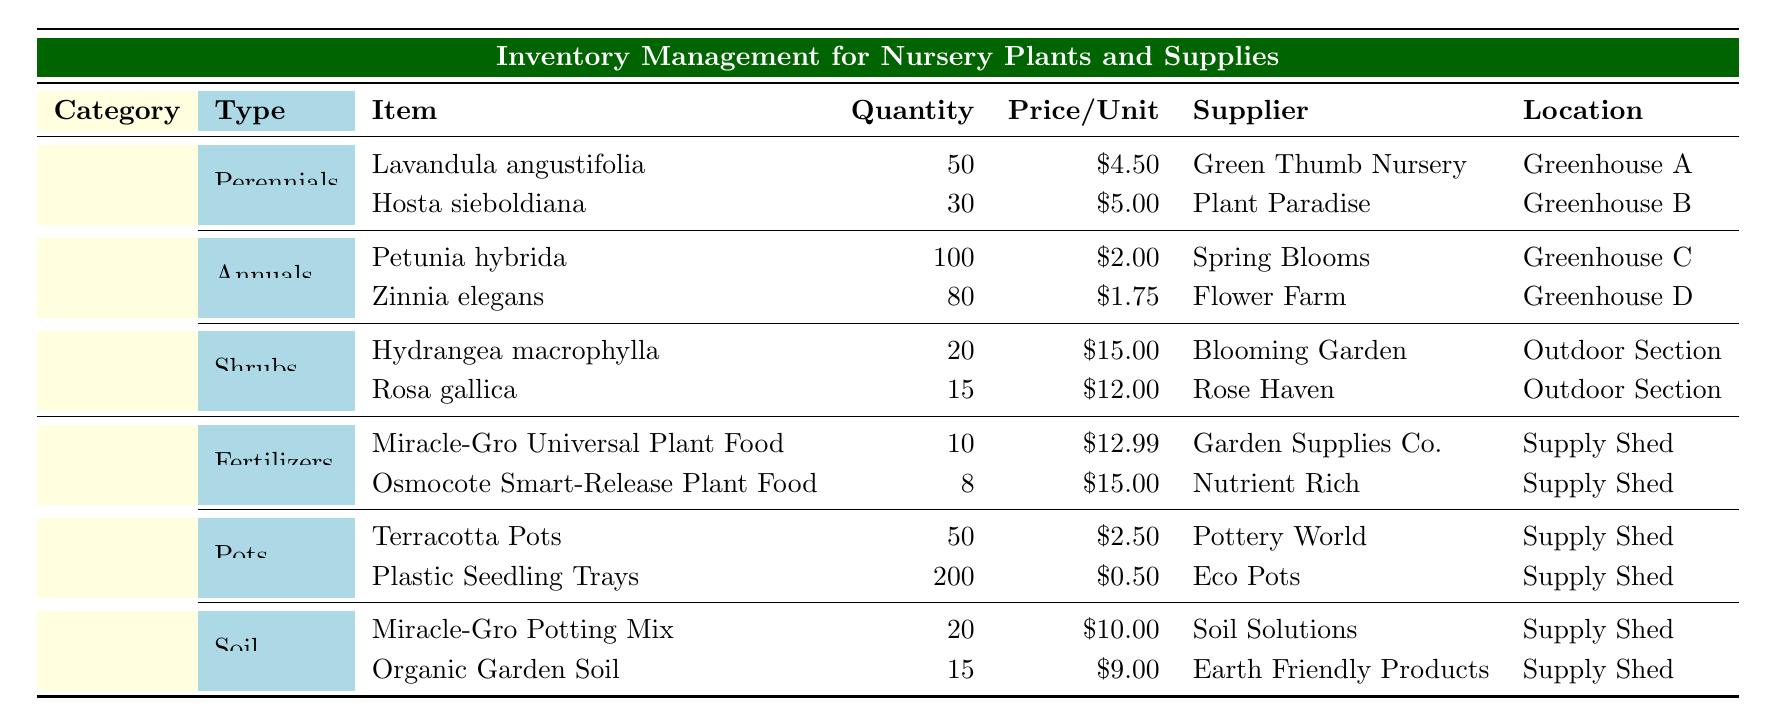What is the total quantity of Perennials available? The table lists two Perennials: Lavandula angustifolia with a quantity of 50 and Hosta sieboldiana with a quantity of 30. Adding these quantities gives 50 + 30 = 80.
Answer: 80 Which plant type has the highest priced item and what is the price? The Shrubs category has the highest priced item, Hydrangea macrophylla at 15.00. Rosa gallica is priced at 12.00, which is lower. Thus, 15.00 is the highest.
Answer: 15.00 Are there more Annuals or Supplies in terms of quantity? The total quantity of Annuals is 100 (Petunia hybrida) + 80 (Zinnia elegans) = 180. For Supplies, we have Fertilizers (10 + 8), Pots (50 + 200), and Soil (20 + 15), summing to 10 + 8 + 50 + 200 + 20 + 15 = 303. Since 303 is greater than 180, Supplies are more.
Answer: No What is the average price of Soil supplies? There are two Soil items: Miracle-Gro Potting Mix costing 10.00 and Organic Garden Soil costing 9.00. The average price is calculated by summing them (10.00 + 9.00) = 19.00 and dividing by 2, giving 19.00 / 2 = 9.50.
Answer: 9.50 Which supplier provides the most items in the inventory? Green Thumb Nursery provides 1 plant; Plant Paradise provides 1 plant; Spring Blooms provides 1 plant; Flower Farm provides 1 plant; Blooming Garden provides 1 shrub; Rose Haven provides 1 shrub; Garden Supplies Co. provides 1 fertilizer; Nutrient Rich provides 1 fertilizer; Pottery World provides 1 pot; Eco Pots provides 1 pot; Soil Solutions provides 1 soil; and Earth Friendly Products provides 1 soil. All suppliers provide either 1 or 2 items, so none stand out.
Answer: No How many plastic seedling trays are available? The quantity of plastic seedling trays is stated explicitly in the table as 200.
Answer: 200 What is the total cost of the plants available? To find the total cost, we will multiply the quantity of each plant by its price per unit and sum them: 
For Perennials: (50 * 4.50) + (30 * 5.00) = 225 + 150 = 375
For Annuals: (100 * 2.00) + (80 * 1.75) = 200 + 140 = 340
For Shrubs: (20 * 15.00) + (15 * 12.00) = 300 + 180 = 480.
So the total cost is 375 + 340 + 480 = 1195.
Answer: 1195 How many items have a price above 10.00? Looking at prices, we have: Hydrangea macrophylla (15.00), Rosa gallica (12.00), Miracle-Gro Universal Plant Food (12.99), and Osmocote Smart-Release Plant Food (15.00), both prices are higher than 10.00. Counting these gives us 4 items.
Answer: 4 Is the quantity of Organic Garden Soil greater than that of Miracle-Gro Universal Plant Food? Organic Garden Soil has a quantity of 15, while Miracle-Gro Universal Plant Food has a quantity of 10. Since 15 is greater than 10, the statement is true.
Answer: Yes 